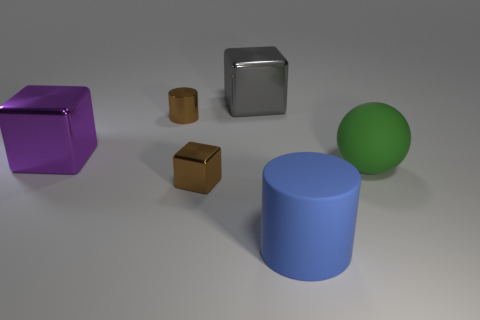Could you speculate on the size relations among the objects? While there's no clear reference for absolute size, the relative sizes of the objects suggest a small-scale arrangement. The purple cube and the blue cylinder appear to be of a similar scale, sizeable compared to the scene. The green sphere is slightly smaller, followed by the reflective cube and the smallest being the brown cube. These size relations offer a sense of depth and balance within the image. 